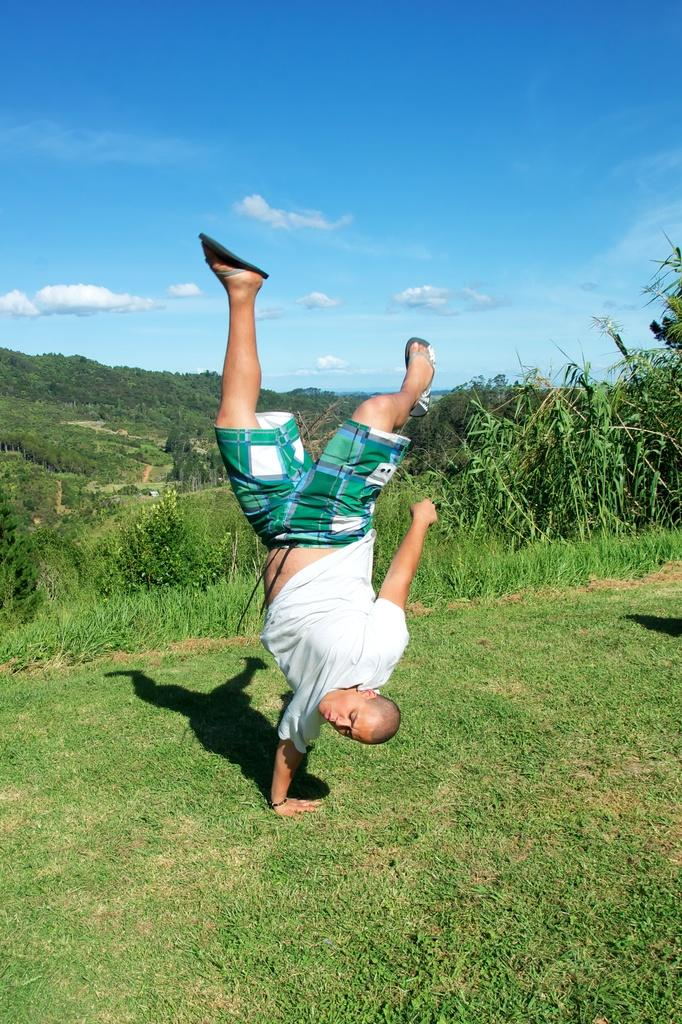What is the main subject of the image? There is a person visible on the ground. What can be seen in the background of the image? The sky is visible in the image. What type of terrain is visible in the image? Grass is visible in the image. How does the person on the ground contribute to the knowledge of the houses in the image? There are no houses present in the image, so the person's knowledge of houses cannot be determined. 